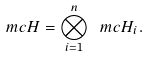<formula> <loc_0><loc_0><loc_500><loc_500>\ m c { H } = \bigotimes _ { i = 1 } ^ { n } \ m c { H } _ { i } .</formula> 